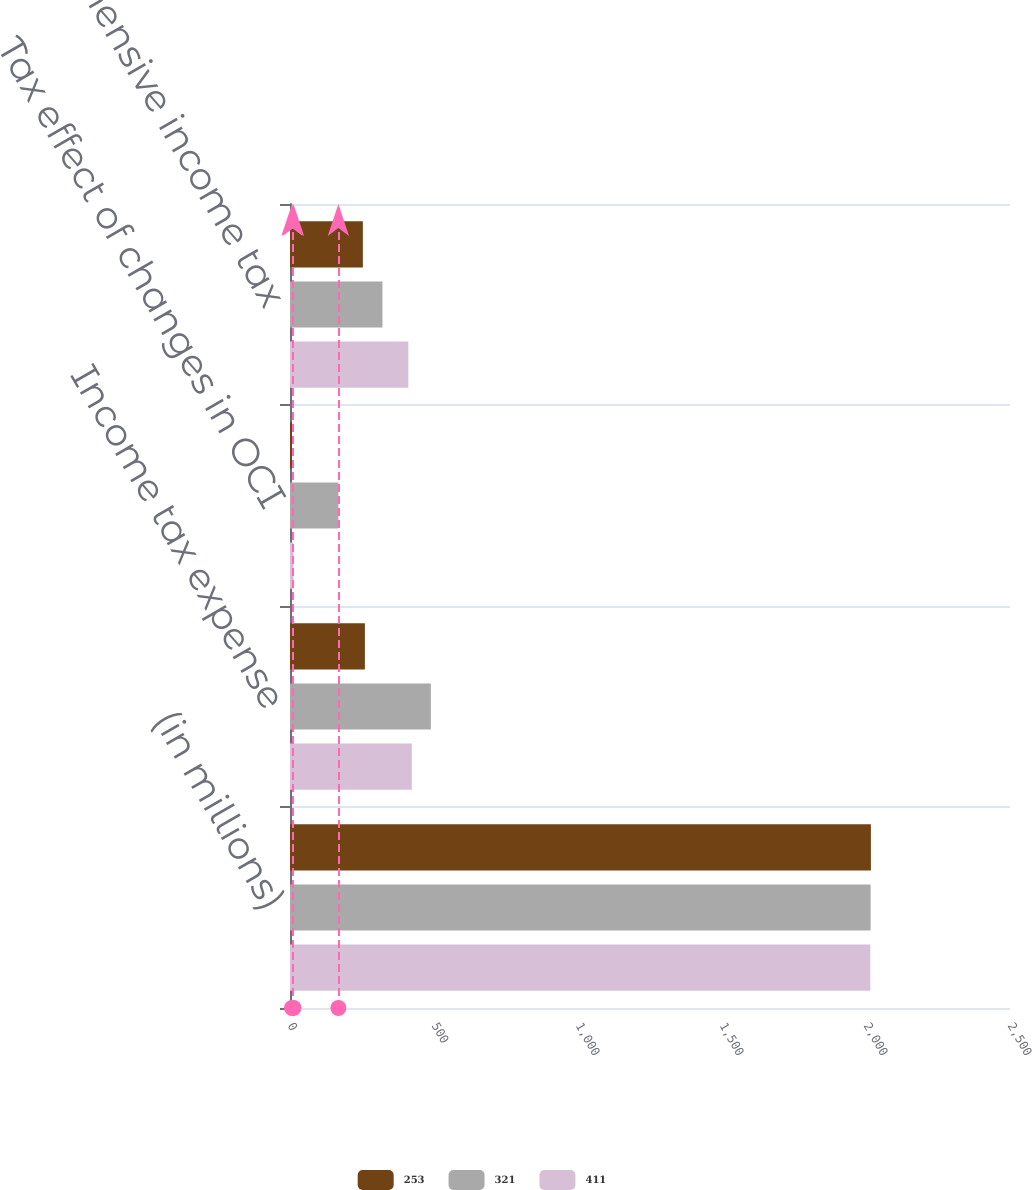<chart> <loc_0><loc_0><loc_500><loc_500><stacked_bar_chart><ecel><fcel>(in millions)<fcel>Income tax expense<fcel>Tax effect of changes in OCI<fcel>Total comprehensive income tax<nl><fcel>253<fcel>2017<fcel>260<fcel>7<fcel>253<nl><fcel>321<fcel>2016<fcel>489<fcel>168<fcel>321<nl><fcel>411<fcel>2015<fcel>423<fcel>12<fcel>411<nl></chart> 